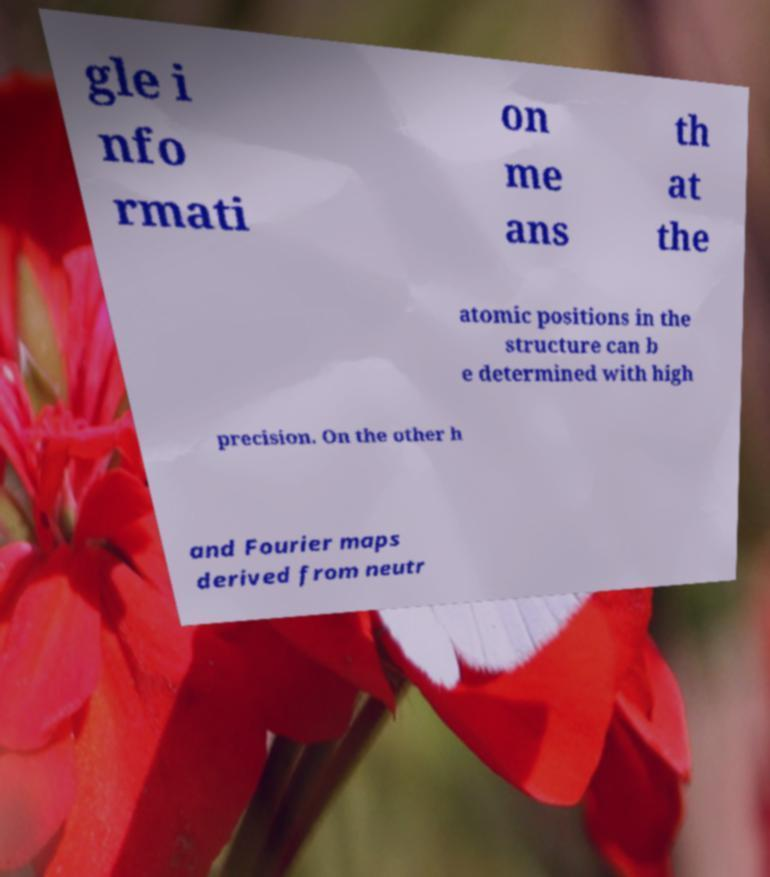Could you assist in decoding the text presented in this image and type it out clearly? gle i nfo rmati on me ans th at the atomic positions in the structure can b e determined with high precision. On the other h and Fourier maps derived from neutr 